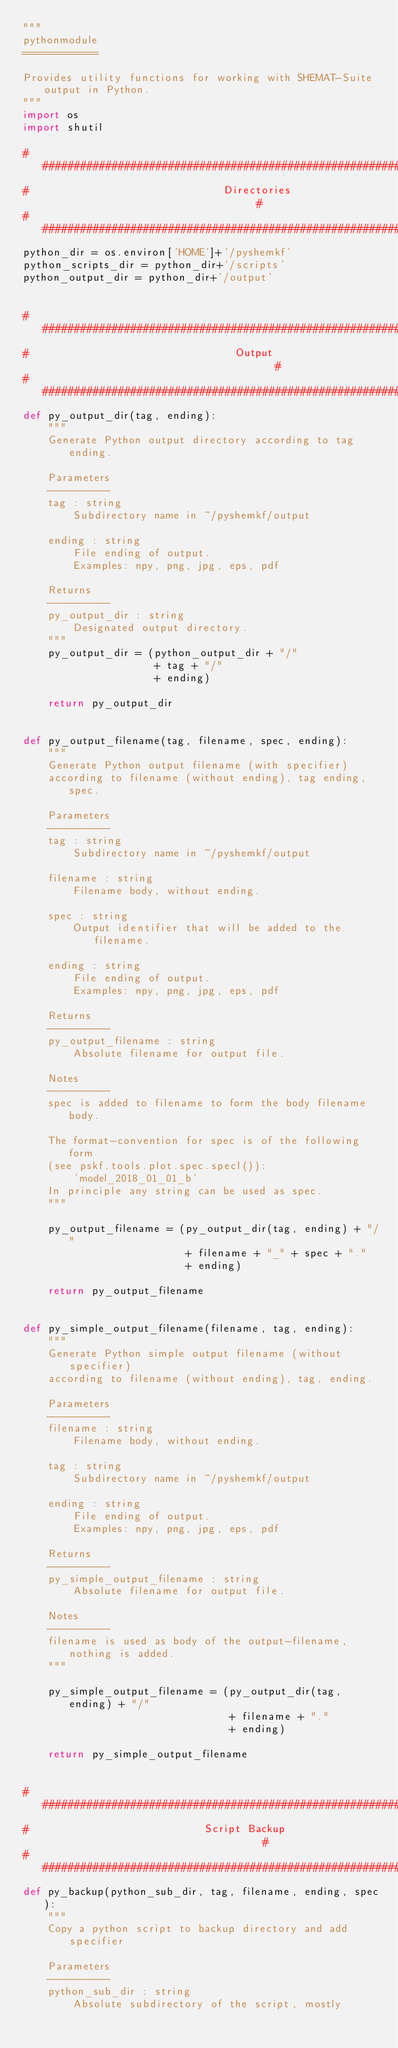<code> <loc_0><loc_0><loc_500><loc_500><_Python_>"""
pythonmodule
============

Provides utility functions for working with SHEMAT-Suite output in Python.
"""
import os
import shutil

###############################################################################
#                               Directories                                   #
###############################################################################
python_dir = os.environ['HOME']+'/pyshemkf'
python_scripts_dir = python_dir+'/scripts'
python_output_dir = python_dir+'/output'


###############################################################################
#                                 Output                                      #
###############################################################################
def py_output_dir(tag, ending):
    """
    Generate Python output directory according to tag ending.

    Parameters
    ----------
    tag : string
        Subdirectory name in ~/pyshemkf/output

    ending : string
        File ending of output.
        Examples: npy, png, jpg, eps, pdf

    Returns
    ----------
    py_output_dir : string
        Designated output directory.
    """
    py_output_dir = (python_output_dir + "/"
                     + tag + "/"
                     + ending)

    return py_output_dir


def py_output_filename(tag, filename, spec, ending):
    """
    Generate Python output filename (with specifier)
    according to filename (without ending), tag ending, spec.

    Parameters
    ----------
    tag : string
        Subdirectory name in ~/pyshemkf/output

    filename : string
        Filename body, without ending.

    spec : string
        Output identifier that will be added to the filename.

    ending : string
        File ending of output.
        Examples: npy, png, jpg, eps, pdf

    Returns
    ----------
    py_output_filename : string
        Absolute filename for output file.

    Notes
    ----------
    spec is added to filename to form the body filename body.

    The format-convention for spec is of the following form
    (see pskf.tools.plot.spec.specl()):
        'model_2018_01_01_b'
    In principle any string can be used as spec.
    """

    py_output_filename = (py_output_dir(tag, ending) + "/"
                          + filename + "_" + spec + "."
                          + ending)

    return py_output_filename


def py_simple_output_filename(filename, tag, ending):
    """
    Generate Python simple output filename (without specifier)
    according to filename (without ending), tag, ending.

    Parameters
    ----------
    filename : string
        Filename body, without ending.

    tag : string
        Subdirectory name in ~/pyshemkf/output

    ending : string
        File ending of output.
        Examples: npy, png, jpg, eps, pdf

    Returns
    ----------
    py_simple_output_filename : string
        Absolute filename for output file.

    Notes
    ----------
    filename is used as body of the output-filename, nothing is added.
    """

    py_simple_output_filename = (py_output_dir(tag, ending) + "/"
                                 + filename + "."
                                 + ending)

    return py_simple_output_filename


###############################################################################
#                            Script Backup                                    #
###############################################################################
def py_backup(python_sub_dir, tag, filename, ending, spec):
    """
    Copy a python script to backup directory and add specifier

    Parameters
    ----------
    python_sub_dir : string
        Absolute subdirectory of the script, mostly</code> 